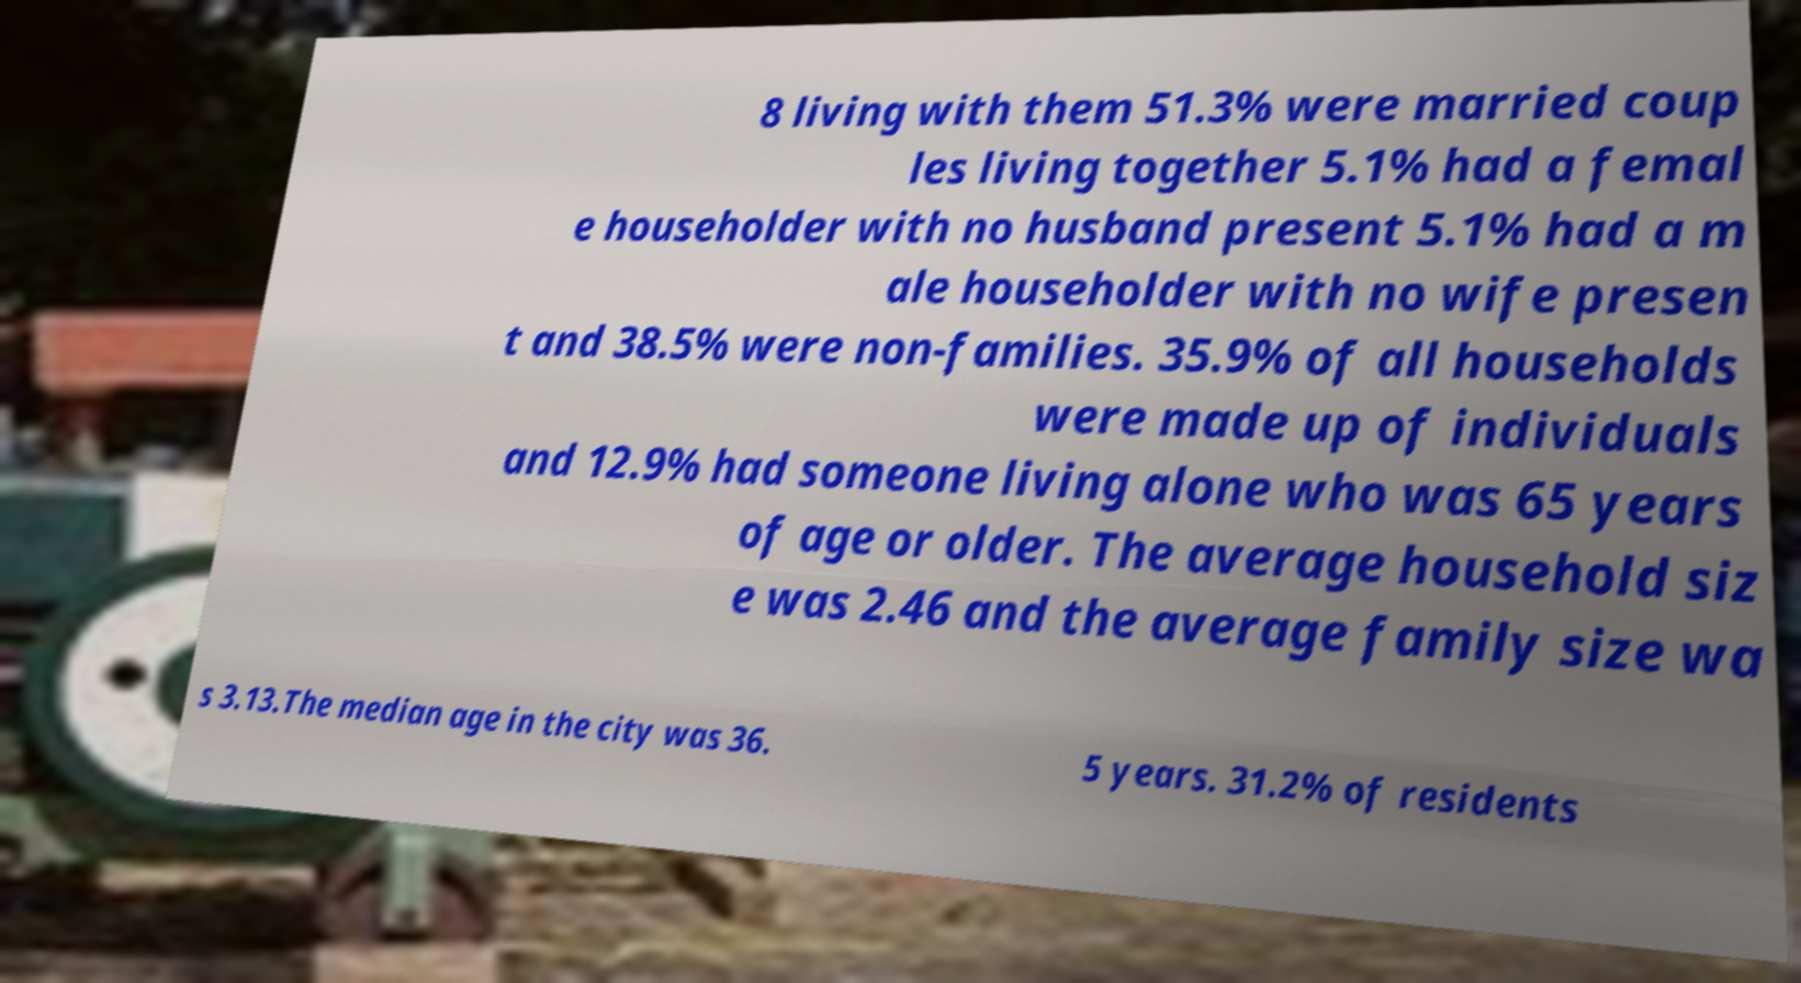Could you assist in decoding the text presented in this image and type it out clearly? 8 living with them 51.3% were married coup les living together 5.1% had a femal e householder with no husband present 5.1% had a m ale householder with no wife presen t and 38.5% were non-families. 35.9% of all households were made up of individuals and 12.9% had someone living alone who was 65 years of age or older. The average household siz e was 2.46 and the average family size wa s 3.13.The median age in the city was 36. 5 years. 31.2% of residents 